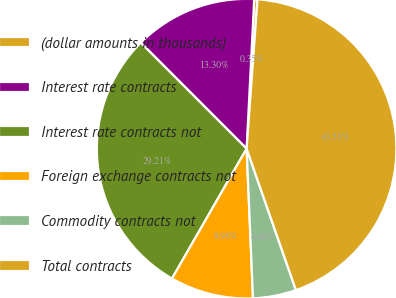Convert chart to OTSL. <chart><loc_0><loc_0><loc_500><loc_500><pie_chart><fcel>(dollar amounts in thousands)<fcel>Interest rate contracts<fcel>Interest rate contracts not<fcel>Foreign exchange contracts not<fcel>Commodity contracts not<fcel>Total contracts<nl><fcel>0.35%<fcel>13.3%<fcel>29.21%<fcel>8.98%<fcel>4.66%<fcel>43.51%<nl></chart> 